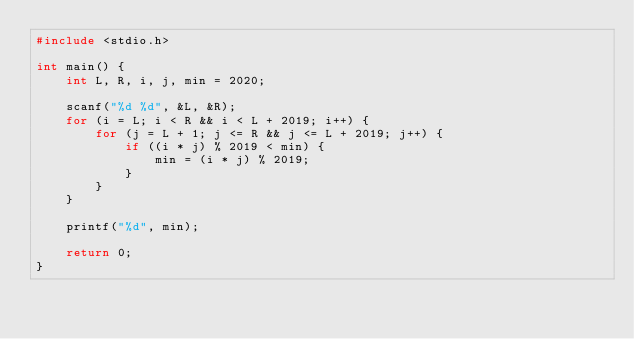<code> <loc_0><loc_0><loc_500><loc_500><_C_>#include <stdio.h>

int main() {
	int L, R, i, j, min = 2020;

	scanf("%d %d", &L, &R);
	for (i = L; i < R && i < L + 2019; i++) {
		for (j = L + 1; j <= R && j <= L + 2019; j++) {
			if ((i * j) % 2019 < min) {
				min = (i * j) % 2019;
			}
		}
	}

	printf("%d", min);
	
	return 0;
} </code> 